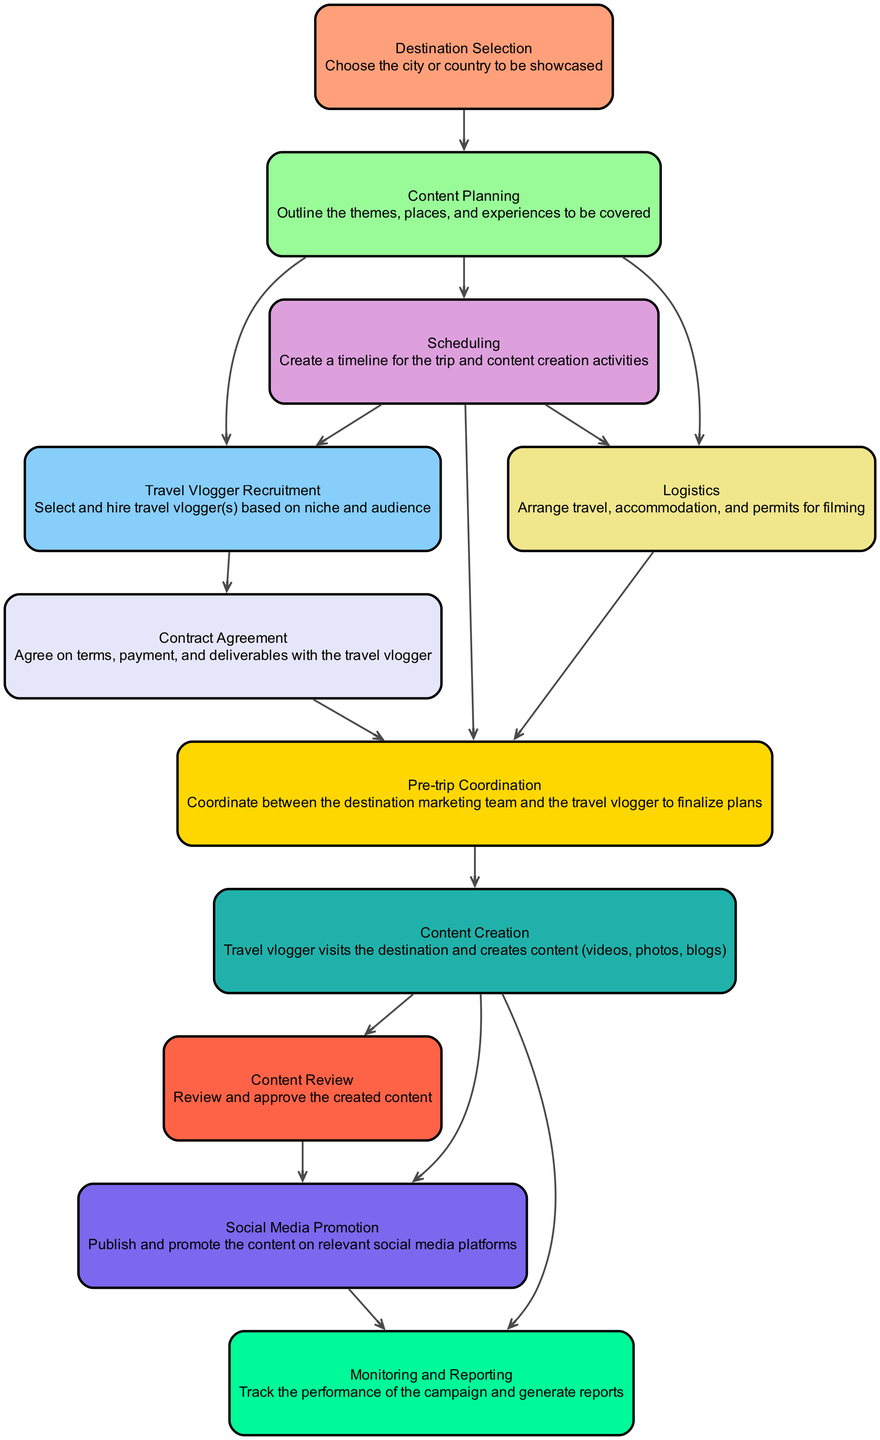What is the first step in the workflow? The first element listed in the diagram is "Destination Selection," which indicates that selecting the city or country is the initial step in the workflow.
Answer: Destination Selection How many connections does "Content Creation" have? Counting the connections leading out from "Content Creation" shows three: "Content Review," "Social Media Promotion," and "Monitoring and Reporting."
Answer: 3 Which element follows "Travel Vlogger Recruitment"? The next element connected to "Travel Vlogger Recruitment" is "Contract Agreement," indicating the subsequent step is to agree on terms with the vlogger after recruitment.
Answer: Contract Agreement What is the last step in this workflow? The final step indicated in the diagram is "Monitoring and Reporting," which shows it is the concluding action after content has been created and promoted.
Answer: Monitoring and Reporting How many elements are there in total? By counting the distinct elements listed in the diagram, there are eleven unique elements contributing to the overall workflow.
Answer: 11 What are the main activities coordinated during "Pre-trip Coordination"? "Pre-trip Coordination" serves as a crucial step involving the coordination between the destination marketing team and the travel vlogger to finalize plans, which covers logistics and scheduling activities.
Answer: Coordination Which step involves reviewing the created content? The step dedicated to reviewing the created content is "Content Review," which is explicitly connected to "Content Creation" as a follow-up task.
Answer: Content Review What connections does "Logistics" make in the workflow? "Logistics" connects to "Pre-trip Coordination," indicating that logistical arrangements play a significant role in preparing before the trip begins.
Answer: Pre-trip Coordination Which element is responsible for promoting the content? The responsibility for promoting the content lies with "Social Media Promotion," which follows "Content Review" and involves publishing on relevant platforms.
Answer: Social Media Promotion 